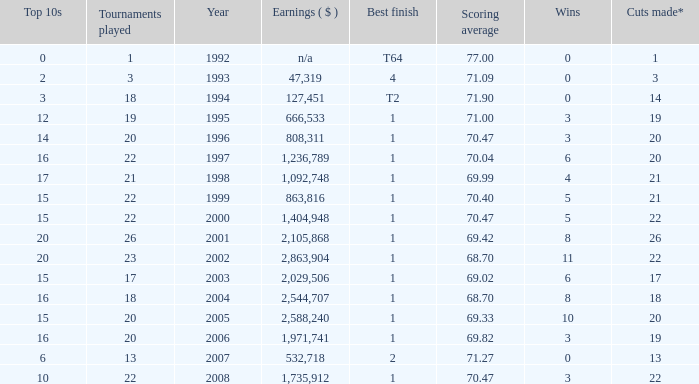Tell me the scoring average for year less than 1998 and wins more than 3 70.04. 